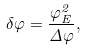<formula> <loc_0><loc_0><loc_500><loc_500>\delta \varphi = \frac { \varphi _ { E } ^ { 2 } } { \Delta \varphi } ,</formula> 